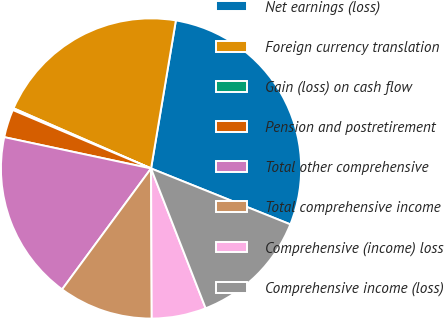Convert chart to OTSL. <chart><loc_0><loc_0><loc_500><loc_500><pie_chart><fcel>Net earnings (loss)<fcel>Foreign currency translation<fcel>Gain (loss) on cash flow<fcel>Pension and postretirement<fcel>Total other comprehensive<fcel>Total comprehensive income<fcel>Comprehensive (income) loss<fcel>Comprehensive income (loss)<nl><fcel>28.43%<fcel>21.08%<fcel>0.2%<fcel>3.02%<fcel>18.25%<fcel>10.17%<fcel>5.85%<fcel>13.0%<nl></chart> 